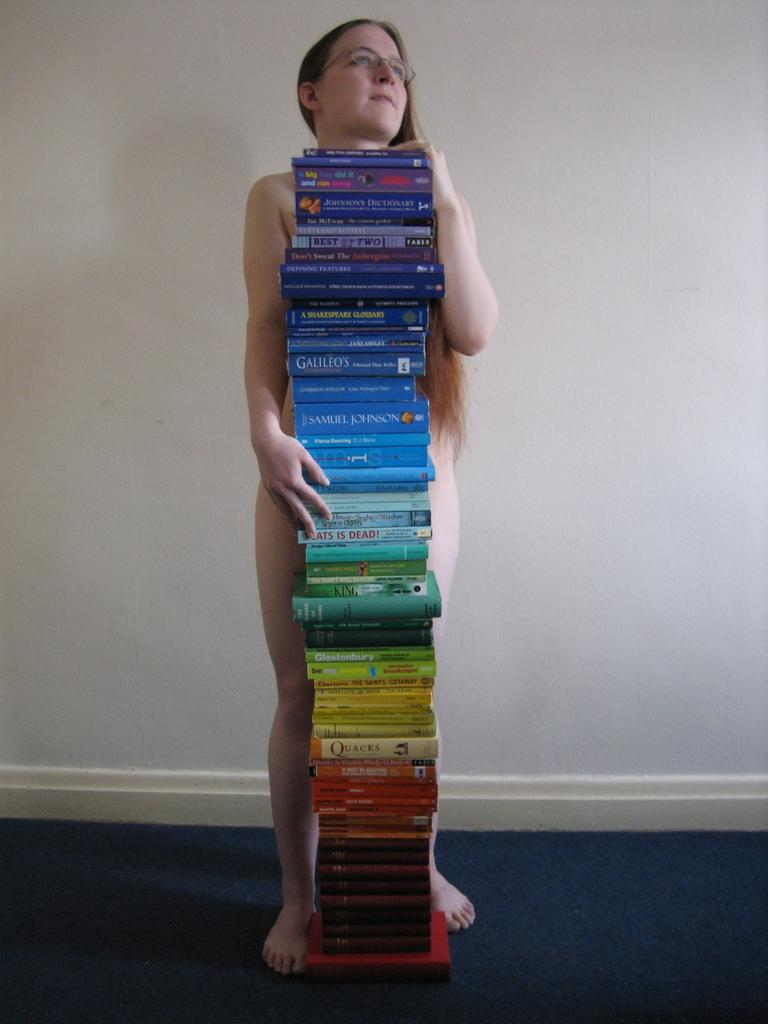Who is the main subject in the image? There is a woman in the image. What is the woman doing in the image? The woman is standing in the image. What can be seen in front of the woman? There is a pile of books in front of the woman. What type of rat can be seen climbing on the books in the image? There is no rat present in the image; only the woman and the pile of books are visible. 